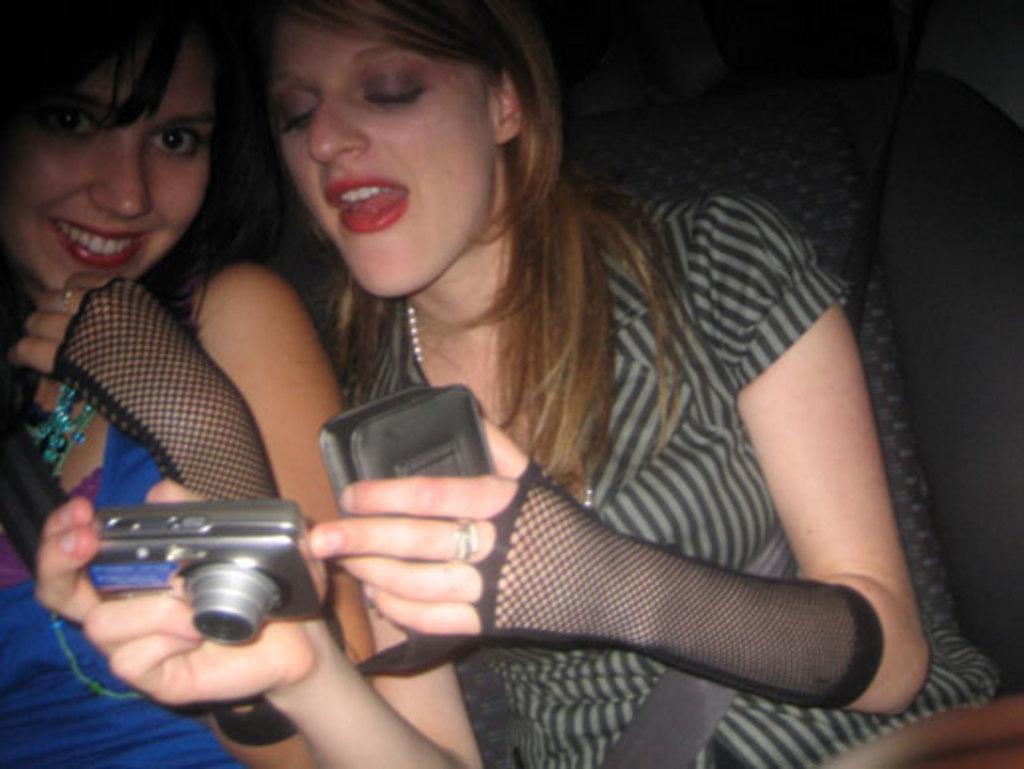How would you summarize this image in a sentence or two? This two women are sitting inside a car and smiling. This woman wore blue dress and this woman is holding camera and looking on to it. 